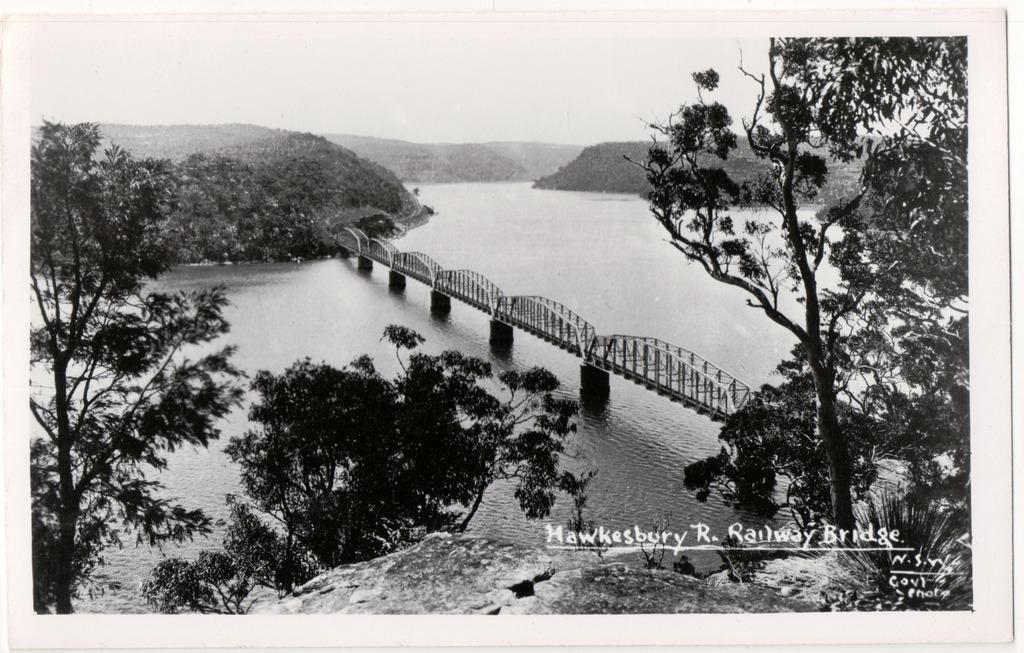Can you describe this image briefly? In this picture there is a poster in the center of the image, which contains of trees, water and a bridge. 